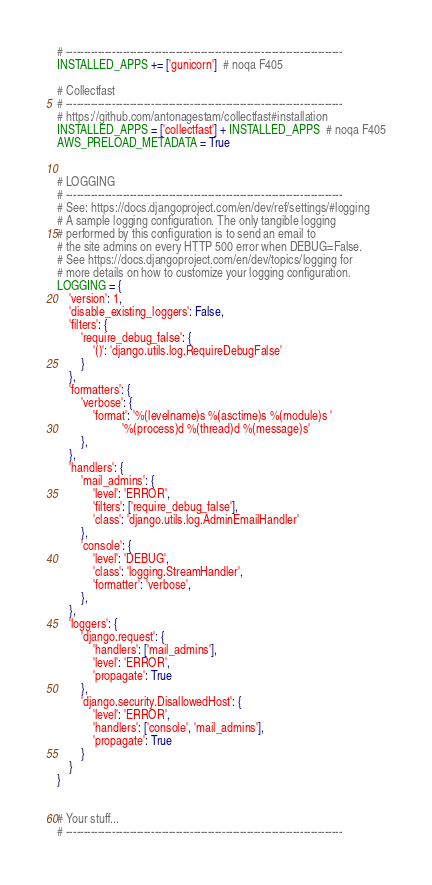<code> <loc_0><loc_0><loc_500><loc_500><_Python_># ------------------------------------------------------------------------------
INSTALLED_APPS += ['gunicorn']  # noqa F405

# Collectfast
# ------------------------------------------------------------------------------
# https://github.com/antonagestam/collectfast#installation
INSTALLED_APPS = ['collectfast'] + INSTALLED_APPS  # noqa F405
AWS_PRELOAD_METADATA = True


# LOGGING
# ------------------------------------------------------------------------------
# See: https://docs.djangoproject.com/en/dev/ref/settings/#logging
# A sample logging configuration. The only tangible logging
# performed by this configuration is to send an email to
# the site admins on every HTTP 500 error when DEBUG=False.
# See https://docs.djangoproject.com/en/dev/topics/logging for
# more details on how to customize your logging configuration.
LOGGING = {
    'version': 1,
    'disable_existing_loggers': False,
    'filters': {
        'require_debug_false': {
            '()': 'django.utils.log.RequireDebugFalse'
        }
    },
    'formatters': {
        'verbose': {
            'format': '%(levelname)s %(asctime)s %(module)s '
                      '%(process)d %(thread)d %(message)s'
        },
    },
    'handlers': {
        'mail_admins': {
            'level': 'ERROR',
            'filters': ['require_debug_false'],
            'class': 'django.utils.log.AdminEmailHandler'
        },
        'console': {
            'level': 'DEBUG',
            'class': 'logging.StreamHandler',
            'formatter': 'verbose',
        },
    },
    'loggers': {
        'django.request': {
            'handlers': ['mail_admins'],
            'level': 'ERROR',
            'propagate': True
        },
        'django.security.DisallowedHost': {
            'level': 'ERROR',
            'handlers': ['console', 'mail_admins'],
            'propagate': True
        }
    }
}


# Your stuff...
# ------------------------------------------------------------------------------
</code> 